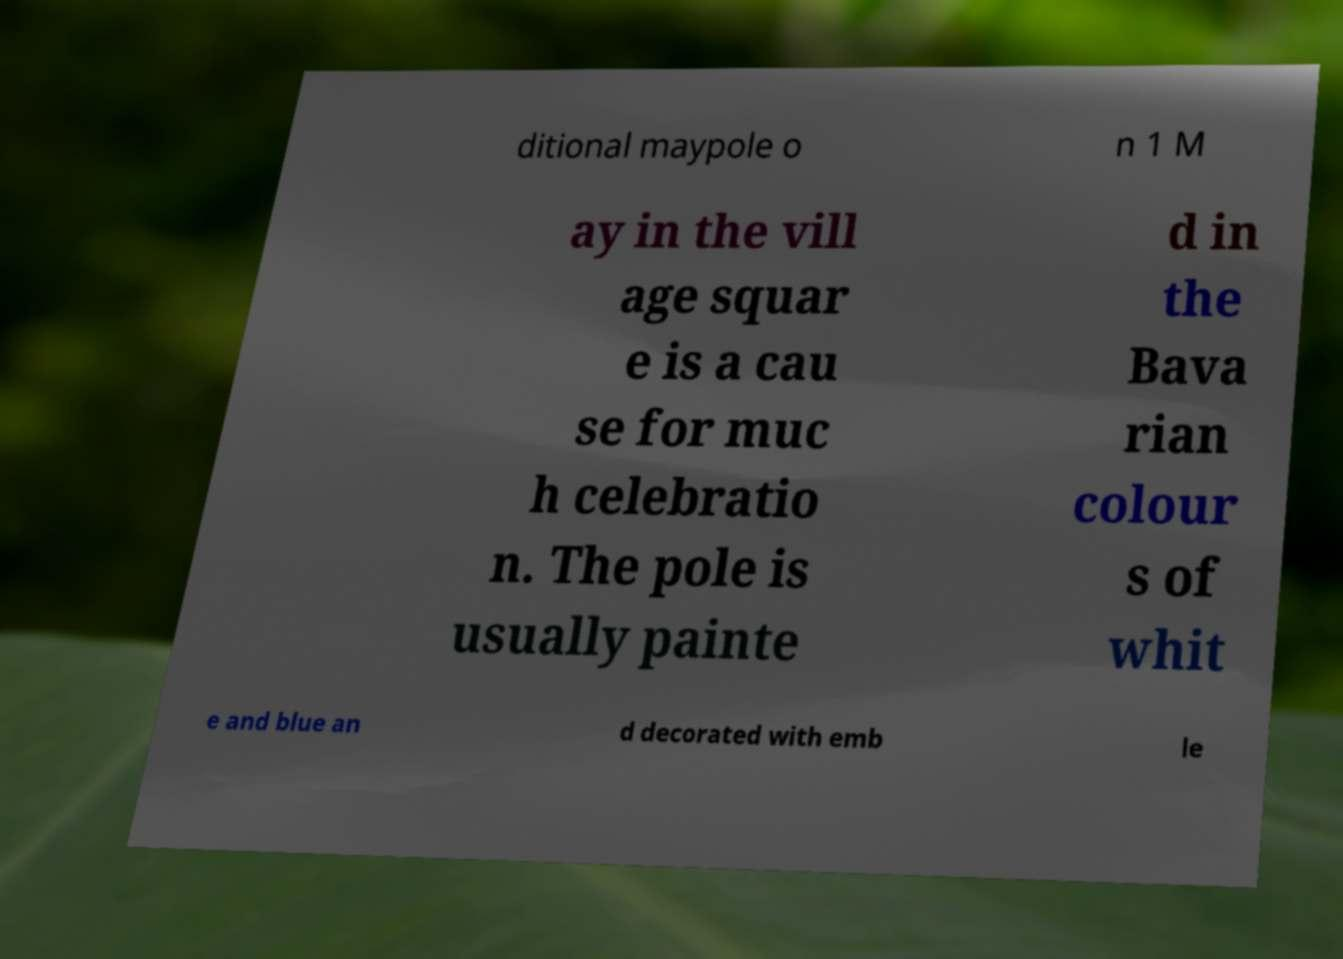I need the written content from this picture converted into text. Can you do that? ditional maypole o n 1 M ay in the vill age squar e is a cau se for muc h celebratio n. The pole is usually painte d in the Bava rian colour s of whit e and blue an d decorated with emb le 